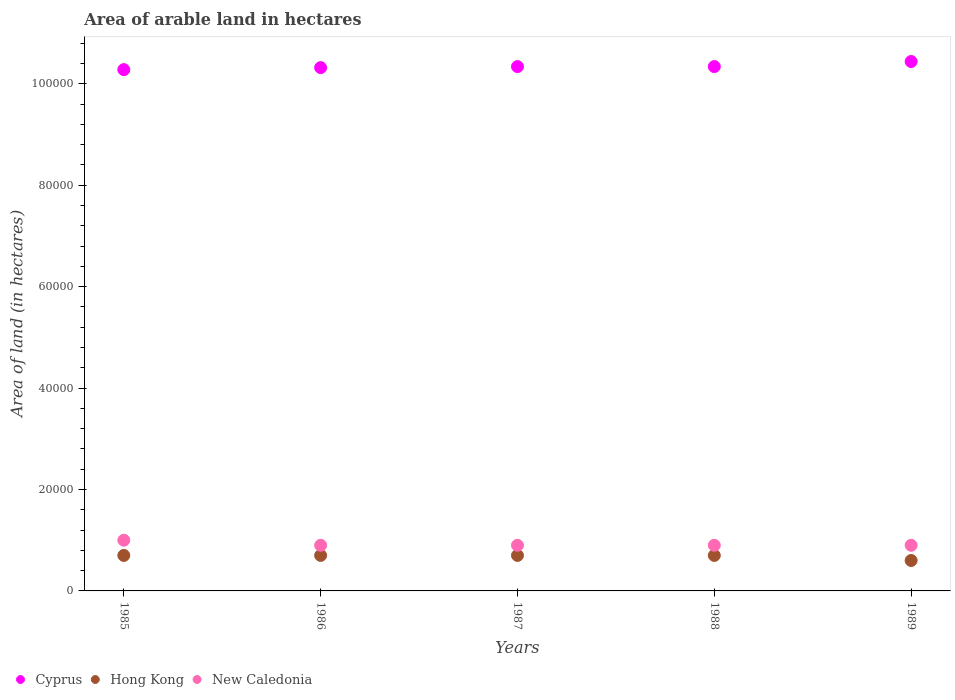What is the total arable land in New Caledonia in 1985?
Your response must be concise. 10000. Across all years, what is the maximum total arable land in Cyprus?
Ensure brevity in your answer.  1.04e+05. Across all years, what is the minimum total arable land in Hong Kong?
Offer a very short reply. 6000. What is the total total arable land in New Caledonia in the graph?
Make the answer very short. 4.60e+04. What is the difference between the total arable land in Cyprus in 1985 and that in 1987?
Offer a very short reply. -600. What is the difference between the total arable land in Hong Kong in 1985 and the total arable land in Cyprus in 1987?
Provide a succinct answer. -9.64e+04. What is the average total arable land in New Caledonia per year?
Provide a succinct answer. 9200. In the year 1987, what is the difference between the total arable land in Cyprus and total arable land in Hong Kong?
Your answer should be very brief. 9.64e+04. In how many years, is the total arable land in Cyprus greater than 32000 hectares?
Provide a short and direct response. 5. Is the difference between the total arable land in Cyprus in 1986 and 1989 greater than the difference between the total arable land in Hong Kong in 1986 and 1989?
Offer a very short reply. No. What is the difference between the highest and the lowest total arable land in New Caledonia?
Make the answer very short. 1000. In how many years, is the total arable land in Cyprus greater than the average total arable land in Cyprus taken over all years?
Ensure brevity in your answer.  1. Is the sum of the total arable land in Hong Kong in 1986 and 1987 greater than the maximum total arable land in Cyprus across all years?
Make the answer very short. No. Does the total arable land in Cyprus monotonically increase over the years?
Your answer should be very brief. No. Is the total arable land in Hong Kong strictly greater than the total arable land in Cyprus over the years?
Your answer should be very brief. No. Is the total arable land in Hong Kong strictly less than the total arable land in New Caledonia over the years?
Offer a terse response. Yes. How many dotlines are there?
Offer a very short reply. 3. Are the values on the major ticks of Y-axis written in scientific E-notation?
Your response must be concise. No. Does the graph contain any zero values?
Give a very brief answer. No. How are the legend labels stacked?
Keep it short and to the point. Horizontal. What is the title of the graph?
Your answer should be very brief. Area of arable land in hectares. Does "Macao" appear as one of the legend labels in the graph?
Provide a succinct answer. No. What is the label or title of the X-axis?
Keep it short and to the point. Years. What is the label or title of the Y-axis?
Ensure brevity in your answer.  Area of land (in hectares). What is the Area of land (in hectares) of Cyprus in 1985?
Give a very brief answer. 1.03e+05. What is the Area of land (in hectares) of Hong Kong in 1985?
Your answer should be compact. 7000. What is the Area of land (in hectares) in New Caledonia in 1985?
Offer a terse response. 10000. What is the Area of land (in hectares) of Cyprus in 1986?
Provide a succinct answer. 1.03e+05. What is the Area of land (in hectares) in Hong Kong in 1986?
Give a very brief answer. 7000. What is the Area of land (in hectares) in New Caledonia in 1986?
Offer a very short reply. 9000. What is the Area of land (in hectares) of Cyprus in 1987?
Ensure brevity in your answer.  1.03e+05. What is the Area of land (in hectares) of Hong Kong in 1987?
Offer a very short reply. 7000. What is the Area of land (in hectares) of New Caledonia in 1987?
Give a very brief answer. 9000. What is the Area of land (in hectares) in Cyprus in 1988?
Your response must be concise. 1.03e+05. What is the Area of land (in hectares) in Hong Kong in 1988?
Your answer should be compact. 7000. What is the Area of land (in hectares) of New Caledonia in 1988?
Give a very brief answer. 9000. What is the Area of land (in hectares) of Cyprus in 1989?
Your answer should be very brief. 1.04e+05. What is the Area of land (in hectares) of Hong Kong in 1989?
Keep it short and to the point. 6000. What is the Area of land (in hectares) in New Caledonia in 1989?
Offer a very short reply. 9000. Across all years, what is the maximum Area of land (in hectares) in Cyprus?
Your answer should be compact. 1.04e+05. Across all years, what is the maximum Area of land (in hectares) in Hong Kong?
Your response must be concise. 7000. Across all years, what is the maximum Area of land (in hectares) in New Caledonia?
Ensure brevity in your answer.  10000. Across all years, what is the minimum Area of land (in hectares) in Cyprus?
Your answer should be compact. 1.03e+05. Across all years, what is the minimum Area of land (in hectares) in Hong Kong?
Provide a short and direct response. 6000. Across all years, what is the minimum Area of land (in hectares) of New Caledonia?
Offer a very short reply. 9000. What is the total Area of land (in hectares) in Cyprus in the graph?
Your response must be concise. 5.17e+05. What is the total Area of land (in hectares) of Hong Kong in the graph?
Offer a very short reply. 3.40e+04. What is the total Area of land (in hectares) of New Caledonia in the graph?
Your answer should be compact. 4.60e+04. What is the difference between the Area of land (in hectares) of Cyprus in 1985 and that in 1986?
Offer a very short reply. -400. What is the difference between the Area of land (in hectares) of Hong Kong in 1985 and that in 1986?
Your answer should be very brief. 0. What is the difference between the Area of land (in hectares) of New Caledonia in 1985 and that in 1986?
Your answer should be compact. 1000. What is the difference between the Area of land (in hectares) of Cyprus in 1985 and that in 1987?
Provide a succinct answer. -600. What is the difference between the Area of land (in hectares) in New Caledonia in 1985 and that in 1987?
Provide a short and direct response. 1000. What is the difference between the Area of land (in hectares) in Cyprus in 1985 and that in 1988?
Offer a terse response. -600. What is the difference between the Area of land (in hectares) in New Caledonia in 1985 and that in 1988?
Keep it short and to the point. 1000. What is the difference between the Area of land (in hectares) in Cyprus in 1985 and that in 1989?
Give a very brief answer. -1600. What is the difference between the Area of land (in hectares) of Hong Kong in 1985 and that in 1989?
Offer a terse response. 1000. What is the difference between the Area of land (in hectares) in Cyprus in 1986 and that in 1987?
Offer a very short reply. -200. What is the difference between the Area of land (in hectares) in Hong Kong in 1986 and that in 1987?
Provide a succinct answer. 0. What is the difference between the Area of land (in hectares) in Cyprus in 1986 and that in 1988?
Ensure brevity in your answer.  -200. What is the difference between the Area of land (in hectares) in New Caledonia in 1986 and that in 1988?
Offer a very short reply. 0. What is the difference between the Area of land (in hectares) in Cyprus in 1986 and that in 1989?
Provide a succinct answer. -1200. What is the difference between the Area of land (in hectares) in Hong Kong in 1986 and that in 1989?
Give a very brief answer. 1000. What is the difference between the Area of land (in hectares) in New Caledonia in 1986 and that in 1989?
Your response must be concise. 0. What is the difference between the Area of land (in hectares) of Cyprus in 1987 and that in 1988?
Your answer should be very brief. 0. What is the difference between the Area of land (in hectares) of Cyprus in 1987 and that in 1989?
Your response must be concise. -1000. What is the difference between the Area of land (in hectares) of Hong Kong in 1987 and that in 1989?
Offer a very short reply. 1000. What is the difference between the Area of land (in hectares) in New Caledonia in 1987 and that in 1989?
Your response must be concise. 0. What is the difference between the Area of land (in hectares) of Cyprus in 1988 and that in 1989?
Keep it short and to the point. -1000. What is the difference between the Area of land (in hectares) of Hong Kong in 1988 and that in 1989?
Keep it short and to the point. 1000. What is the difference between the Area of land (in hectares) in Cyprus in 1985 and the Area of land (in hectares) in Hong Kong in 1986?
Provide a short and direct response. 9.58e+04. What is the difference between the Area of land (in hectares) in Cyprus in 1985 and the Area of land (in hectares) in New Caledonia in 1986?
Offer a very short reply. 9.38e+04. What is the difference between the Area of land (in hectares) in Hong Kong in 1985 and the Area of land (in hectares) in New Caledonia in 1986?
Offer a very short reply. -2000. What is the difference between the Area of land (in hectares) of Cyprus in 1985 and the Area of land (in hectares) of Hong Kong in 1987?
Provide a succinct answer. 9.58e+04. What is the difference between the Area of land (in hectares) of Cyprus in 1985 and the Area of land (in hectares) of New Caledonia in 1987?
Offer a very short reply. 9.38e+04. What is the difference between the Area of land (in hectares) in Hong Kong in 1985 and the Area of land (in hectares) in New Caledonia in 1987?
Offer a terse response. -2000. What is the difference between the Area of land (in hectares) of Cyprus in 1985 and the Area of land (in hectares) of Hong Kong in 1988?
Offer a very short reply. 9.58e+04. What is the difference between the Area of land (in hectares) of Cyprus in 1985 and the Area of land (in hectares) of New Caledonia in 1988?
Provide a short and direct response. 9.38e+04. What is the difference between the Area of land (in hectares) in Hong Kong in 1985 and the Area of land (in hectares) in New Caledonia in 1988?
Your answer should be very brief. -2000. What is the difference between the Area of land (in hectares) of Cyprus in 1985 and the Area of land (in hectares) of Hong Kong in 1989?
Your answer should be very brief. 9.68e+04. What is the difference between the Area of land (in hectares) of Cyprus in 1985 and the Area of land (in hectares) of New Caledonia in 1989?
Make the answer very short. 9.38e+04. What is the difference between the Area of land (in hectares) in Hong Kong in 1985 and the Area of land (in hectares) in New Caledonia in 1989?
Offer a terse response. -2000. What is the difference between the Area of land (in hectares) in Cyprus in 1986 and the Area of land (in hectares) in Hong Kong in 1987?
Keep it short and to the point. 9.62e+04. What is the difference between the Area of land (in hectares) in Cyprus in 1986 and the Area of land (in hectares) in New Caledonia in 1987?
Give a very brief answer. 9.42e+04. What is the difference between the Area of land (in hectares) of Hong Kong in 1986 and the Area of land (in hectares) of New Caledonia in 1987?
Provide a short and direct response. -2000. What is the difference between the Area of land (in hectares) in Cyprus in 1986 and the Area of land (in hectares) in Hong Kong in 1988?
Offer a very short reply. 9.62e+04. What is the difference between the Area of land (in hectares) of Cyprus in 1986 and the Area of land (in hectares) of New Caledonia in 1988?
Provide a succinct answer. 9.42e+04. What is the difference between the Area of land (in hectares) in Hong Kong in 1986 and the Area of land (in hectares) in New Caledonia in 1988?
Provide a succinct answer. -2000. What is the difference between the Area of land (in hectares) in Cyprus in 1986 and the Area of land (in hectares) in Hong Kong in 1989?
Give a very brief answer. 9.72e+04. What is the difference between the Area of land (in hectares) of Cyprus in 1986 and the Area of land (in hectares) of New Caledonia in 1989?
Provide a short and direct response. 9.42e+04. What is the difference between the Area of land (in hectares) in Hong Kong in 1986 and the Area of land (in hectares) in New Caledonia in 1989?
Make the answer very short. -2000. What is the difference between the Area of land (in hectares) in Cyprus in 1987 and the Area of land (in hectares) in Hong Kong in 1988?
Provide a succinct answer. 9.64e+04. What is the difference between the Area of land (in hectares) of Cyprus in 1987 and the Area of land (in hectares) of New Caledonia in 1988?
Your answer should be compact. 9.44e+04. What is the difference between the Area of land (in hectares) of Hong Kong in 1987 and the Area of land (in hectares) of New Caledonia in 1988?
Ensure brevity in your answer.  -2000. What is the difference between the Area of land (in hectares) of Cyprus in 1987 and the Area of land (in hectares) of Hong Kong in 1989?
Your answer should be very brief. 9.74e+04. What is the difference between the Area of land (in hectares) in Cyprus in 1987 and the Area of land (in hectares) in New Caledonia in 1989?
Keep it short and to the point. 9.44e+04. What is the difference between the Area of land (in hectares) in Hong Kong in 1987 and the Area of land (in hectares) in New Caledonia in 1989?
Keep it short and to the point. -2000. What is the difference between the Area of land (in hectares) in Cyprus in 1988 and the Area of land (in hectares) in Hong Kong in 1989?
Provide a succinct answer. 9.74e+04. What is the difference between the Area of land (in hectares) in Cyprus in 1988 and the Area of land (in hectares) in New Caledonia in 1989?
Offer a very short reply. 9.44e+04. What is the difference between the Area of land (in hectares) in Hong Kong in 1988 and the Area of land (in hectares) in New Caledonia in 1989?
Make the answer very short. -2000. What is the average Area of land (in hectares) in Cyprus per year?
Provide a short and direct response. 1.03e+05. What is the average Area of land (in hectares) of Hong Kong per year?
Your answer should be very brief. 6800. What is the average Area of land (in hectares) of New Caledonia per year?
Provide a succinct answer. 9200. In the year 1985, what is the difference between the Area of land (in hectares) in Cyprus and Area of land (in hectares) in Hong Kong?
Your response must be concise. 9.58e+04. In the year 1985, what is the difference between the Area of land (in hectares) of Cyprus and Area of land (in hectares) of New Caledonia?
Offer a very short reply. 9.28e+04. In the year 1985, what is the difference between the Area of land (in hectares) in Hong Kong and Area of land (in hectares) in New Caledonia?
Your answer should be compact. -3000. In the year 1986, what is the difference between the Area of land (in hectares) of Cyprus and Area of land (in hectares) of Hong Kong?
Your answer should be compact. 9.62e+04. In the year 1986, what is the difference between the Area of land (in hectares) of Cyprus and Area of land (in hectares) of New Caledonia?
Provide a succinct answer. 9.42e+04. In the year 1986, what is the difference between the Area of land (in hectares) of Hong Kong and Area of land (in hectares) of New Caledonia?
Offer a very short reply. -2000. In the year 1987, what is the difference between the Area of land (in hectares) of Cyprus and Area of land (in hectares) of Hong Kong?
Your answer should be very brief. 9.64e+04. In the year 1987, what is the difference between the Area of land (in hectares) of Cyprus and Area of land (in hectares) of New Caledonia?
Your response must be concise. 9.44e+04. In the year 1987, what is the difference between the Area of land (in hectares) in Hong Kong and Area of land (in hectares) in New Caledonia?
Make the answer very short. -2000. In the year 1988, what is the difference between the Area of land (in hectares) in Cyprus and Area of land (in hectares) in Hong Kong?
Offer a terse response. 9.64e+04. In the year 1988, what is the difference between the Area of land (in hectares) of Cyprus and Area of land (in hectares) of New Caledonia?
Your answer should be compact. 9.44e+04. In the year 1988, what is the difference between the Area of land (in hectares) in Hong Kong and Area of land (in hectares) in New Caledonia?
Offer a very short reply. -2000. In the year 1989, what is the difference between the Area of land (in hectares) of Cyprus and Area of land (in hectares) of Hong Kong?
Ensure brevity in your answer.  9.84e+04. In the year 1989, what is the difference between the Area of land (in hectares) in Cyprus and Area of land (in hectares) in New Caledonia?
Your response must be concise. 9.54e+04. In the year 1989, what is the difference between the Area of land (in hectares) of Hong Kong and Area of land (in hectares) of New Caledonia?
Offer a very short reply. -3000. What is the ratio of the Area of land (in hectares) in Cyprus in 1985 to that in 1986?
Keep it short and to the point. 1. What is the ratio of the Area of land (in hectares) in Hong Kong in 1985 to that in 1986?
Ensure brevity in your answer.  1. What is the ratio of the Area of land (in hectares) in New Caledonia in 1985 to that in 1986?
Offer a very short reply. 1.11. What is the ratio of the Area of land (in hectares) in Hong Kong in 1985 to that in 1987?
Give a very brief answer. 1. What is the ratio of the Area of land (in hectares) of New Caledonia in 1985 to that in 1987?
Provide a short and direct response. 1.11. What is the ratio of the Area of land (in hectares) in Cyprus in 1985 to that in 1988?
Give a very brief answer. 0.99. What is the ratio of the Area of land (in hectares) in Cyprus in 1985 to that in 1989?
Offer a very short reply. 0.98. What is the ratio of the Area of land (in hectares) in Hong Kong in 1985 to that in 1989?
Give a very brief answer. 1.17. What is the ratio of the Area of land (in hectares) in New Caledonia in 1985 to that in 1989?
Keep it short and to the point. 1.11. What is the ratio of the Area of land (in hectares) of Hong Kong in 1986 to that in 1988?
Provide a succinct answer. 1. What is the ratio of the Area of land (in hectares) in New Caledonia in 1986 to that in 1988?
Offer a very short reply. 1. What is the ratio of the Area of land (in hectares) of Cyprus in 1987 to that in 1988?
Offer a very short reply. 1. What is the ratio of the Area of land (in hectares) of Hong Kong in 1987 to that in 1988?
Give a very brief answer. 1. What is the ratio of the Area of land (in hectares) of Hong Kong in 1987 to that in 1989?
Offer a very short reply. 1.17. What is the ratio of the Area of land (in hectares) in New Caledonia in 1987 to that in 1989?
Offer a terse response. 1. What is the ratio of the Area of land (in hectares) of Cyprus in 1988 to that in 1989?
Provide a succinct answer. 0.99. What is the difference between the highest and the lowest Area of land (in hectares) of Cyprus?
Your response must be concise. 1600. What is the difference between the highest and the lowest Area of land (in hectares) of Hong Kong?
Your answer should be very brief. 1000. 